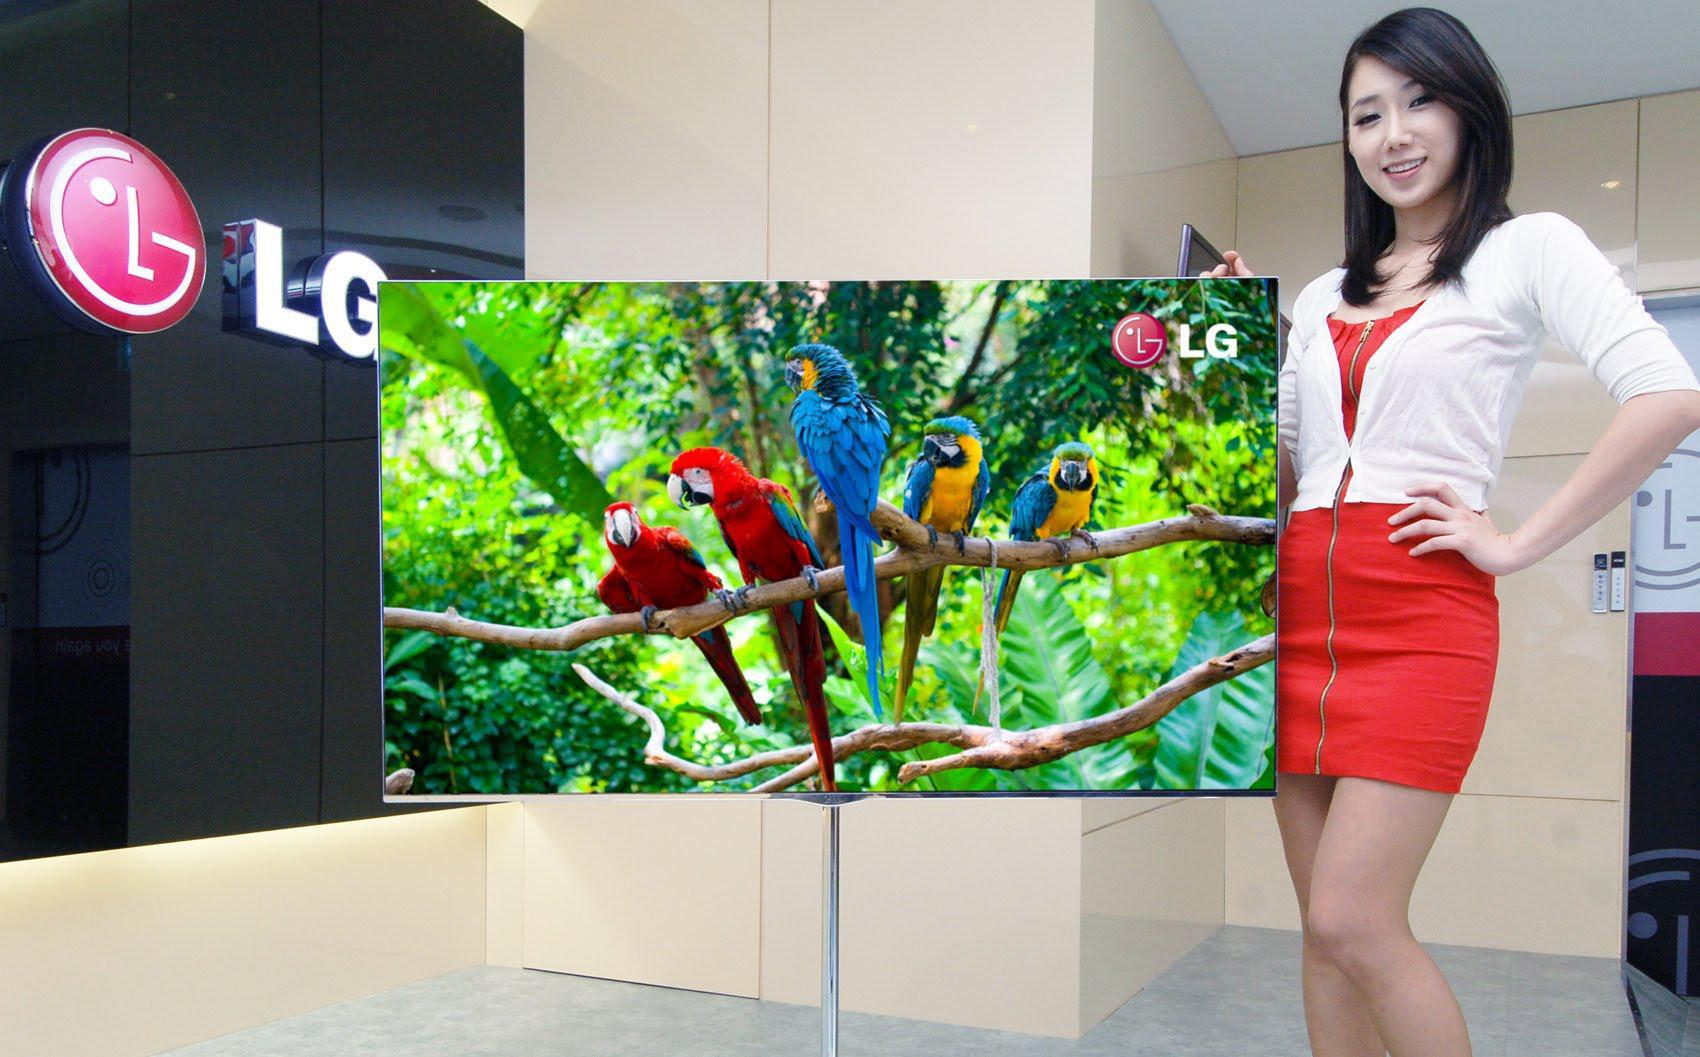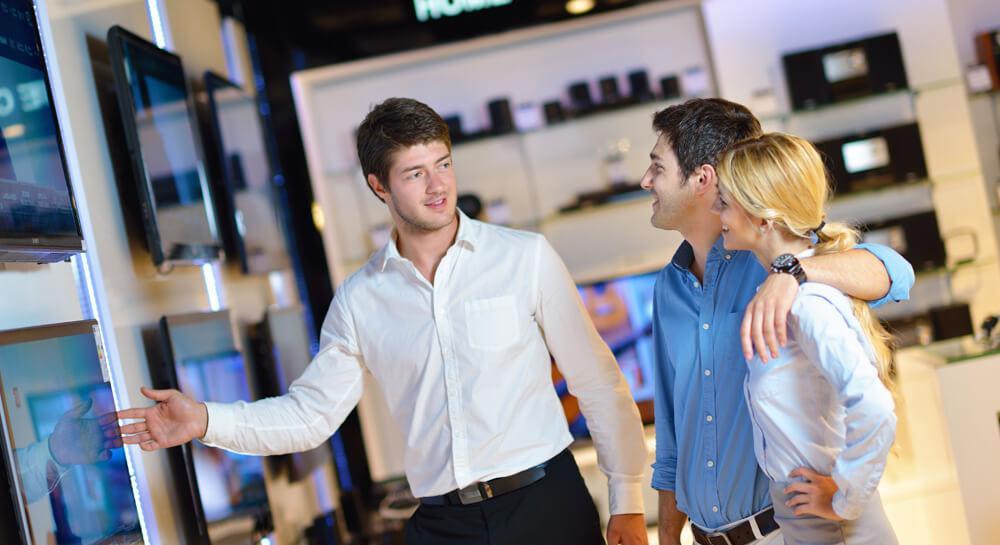The first image is the image on the left, the second image is the image on the right. Analyze the images presented: Is the assertion "In one image, a man and woman are standing together looking at a display television, the man's arm stretched out pointing at the screen." valid? Answer yes or no. No. The first image is the image on the left, the second image is the image on the right. Evaluate the accuracy of this statement regarding the images: "At least one of the images shows a man with his arm around a woman's shoulder.". Is it true? Answer yes or no. Yes. 